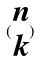Convert formula to latex. <formula><loc_0><loc_0><loc_500><loc_500>( \begin{matrix} n \\ k \end{matrix} )</formula> 